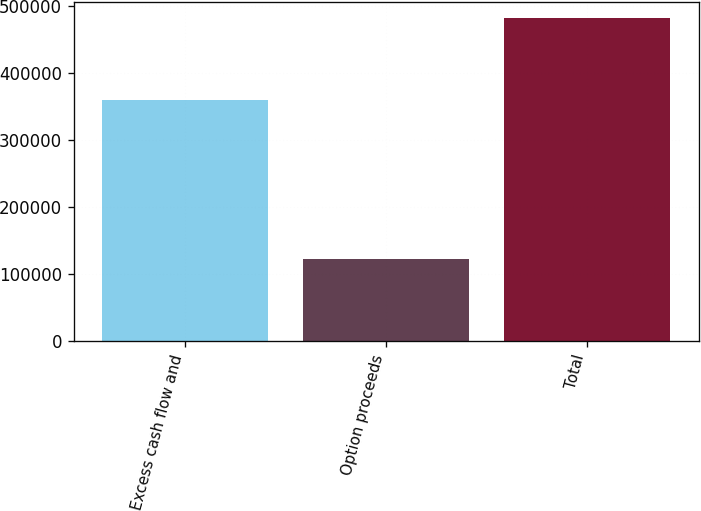<chart> <loc_0><loc_0><loc_500><loc_500><bar_chart><fcel>Excess cash flow and<fcel>Option proceeds<fcel>Total<nl><fcel>360001<fcel>122263<fcel>482264<nl></chart> 